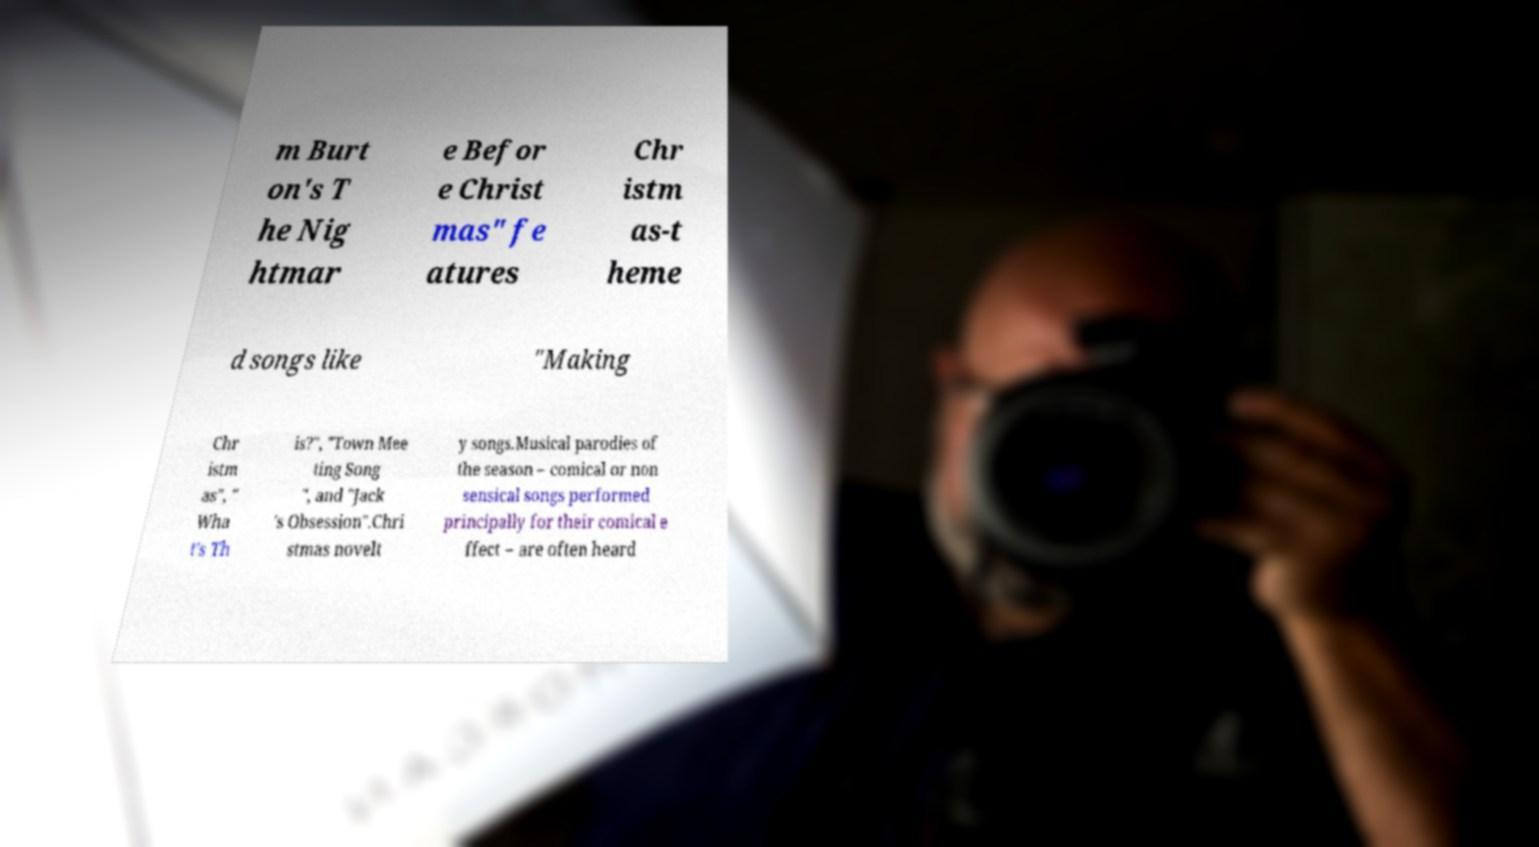Can you read and provide the text displayed in the image?This photo seems to have some interesting text. Can you extract and type it out for me? m Burt on's T he Nig htmar e Befor e Christ mas" fe atures Chr istm as-t heme d songs like "Making Chr istm as", " Wha t's Th is?", "Town Mee ting Song ", and "Jack 's Obsession".Chri stmas novelt y songs.Musical parodies of the season – comical or non sensical songs performed principally for their comical e ffect – are often heard 